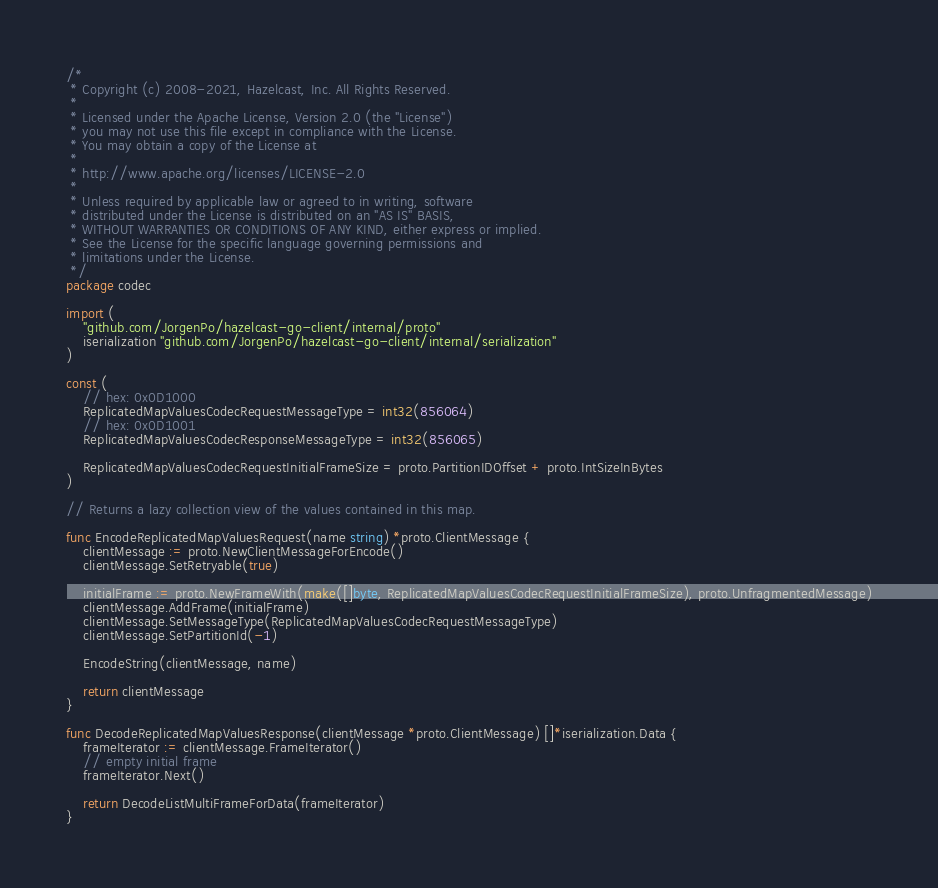<code> <loc_0><loc_0><loc_500><loc_500><_Go_>/*
 * Copyright (c) 2008-2021, Hazelcast, Inc. All Rights Reserved.
 *
 * Licensed under the Apache License, Version 2.0 (the "License")
 * you may not use this file except in compliance with the License.
 * You may obtain a copy of the License at
 *
 * http://www.apache.org/licenses/LICENSE-2.0
 *
 * Unless required by applicable law or agreed to in writing, software
 * distributed under the License is distributed on an "AS IS" BASIS,
 * WITHOUT WARRANTIES OR CONDITIONS OF ANY KIND, either express or implied.
 * See the License for the specific language governing permissions and
 * limitations under the License.
 */
package codec

import (
	"github.com/JorgenPo/hazelcast-go-client/internal/proto"
	iserialization "github.com/JorgenPo/hazelcast-go-client/internal/serialization"
)

const (
	// hex: 0x0D1000
	ReplicatedMapValuesCodecRequestMessageType = int32(856064)
	// hex: 0x0D1001
	ReplicatedMapValuesCodecResponseMessageType = int32(856065)

	ReplicatedMapValuesCodecRequestInitialFrameSize = proto.PartitionIDOffset + proto.IntSizeInBytes
)

// Returns a lazy collection view of the values contained in this map.

func EncodeReplicatedMapValuesRequest(name string) *proto.ClientMessage {
	clientMessage := proto.NewClientMessageForEncode()
	clientMessage.SetRetryable(true)

	initialFrame := proto.NewFrameWith(make([]byte, ReplicatedMapValuesCodecRequestInitialFrameSize), proto.UnfragmentedMessage)
	clientMessage.AddFrame(initialFrame)
	clientMessage.SetMessageType(ReplicatedMapValuesCodecRequestMessageType)
	clientMessage.SetPartitionId(-1)

	EncodeString(clientMessage, name)

	return clientMessage
}

func DecodeReplicatedMapValuesResponse(clientMessage *proto.ClientMessage) []*iserialization.Data {
	frameIterator := clientMessage.FrameIterator()
	// empty initial frame
	frameIterator.Next()

	return DecodeListMultiFrameForData(frameIterator)
}
</code> 